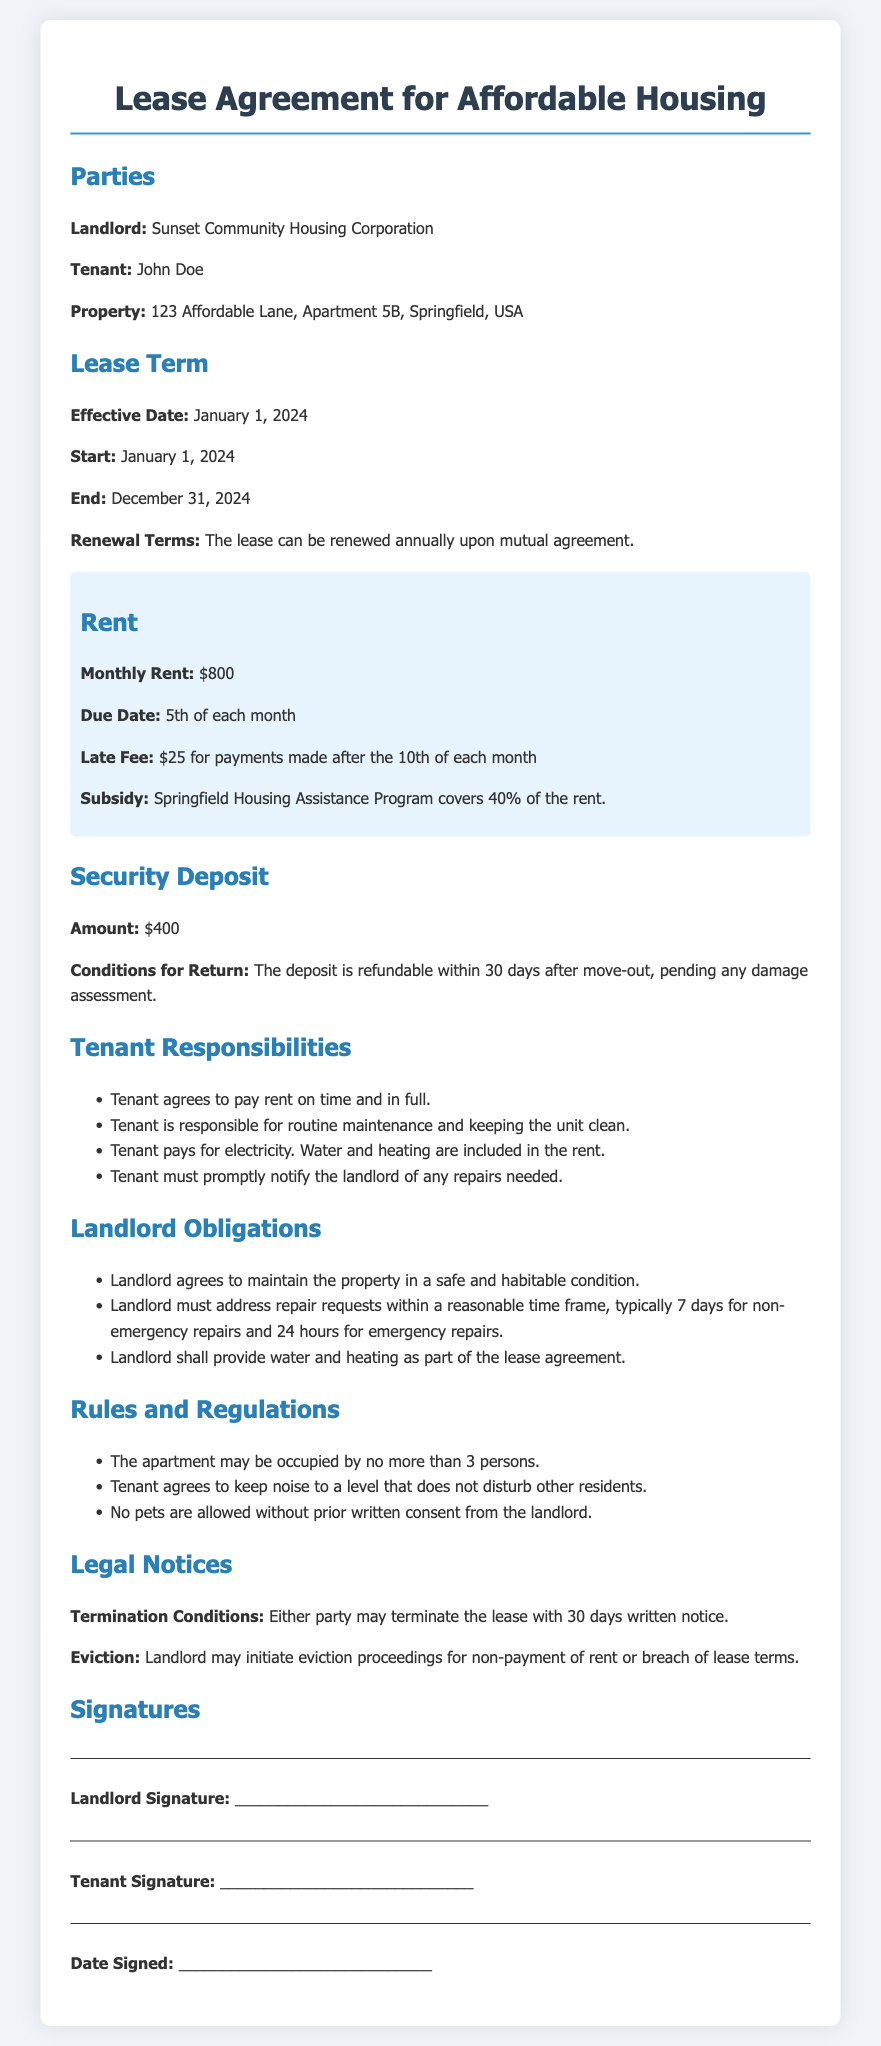What is the effective date of the lease? The effective date is specified in the Lease Term section, detailing when the lease begins.
Answer: January 1, 2024 Who is the landlord? The landlord's name is clearly stated at the beginning of the document under the Parties section.
Answer: Sunset Community Housing Corporation What is the amount of the security deposit? The document specifies the amount of the security deposit under the Security Deposit section.
Answer: $400 How much rent does the tenant pay monthly? The monthly rent amount is highlighted in the Rent section of the document.
Answer: $800 What is the late fee for rent payments? The late fee is described in the Rent section concerning late rent payments.
Answer: $25 How long does the tenant have to notify the landlord of needed repairs? The tenant’s responsibility regarding repairs is outlined and implies the need for prompt notification.
Answer: Promptly What are the conditions for terminating the lease? The document states the termination conditions in the Legal Notices section.
Answer: 30 days written notice What utilities does the tenant pay for? The Tenant Responsibilities section enumerates the utilities for which the tenant is responsible.
Answer: Electricity What is the maximum number of occupants allowed in the apartment? The Rules and Regulations section specifies the occupancy limit.
Answer: 3 persons What is the renewal term for the lease? The renewal terms mentioned in the Lease Term section outline the agreement on lease continuation.
Answer: Annually upon mutual agreement 